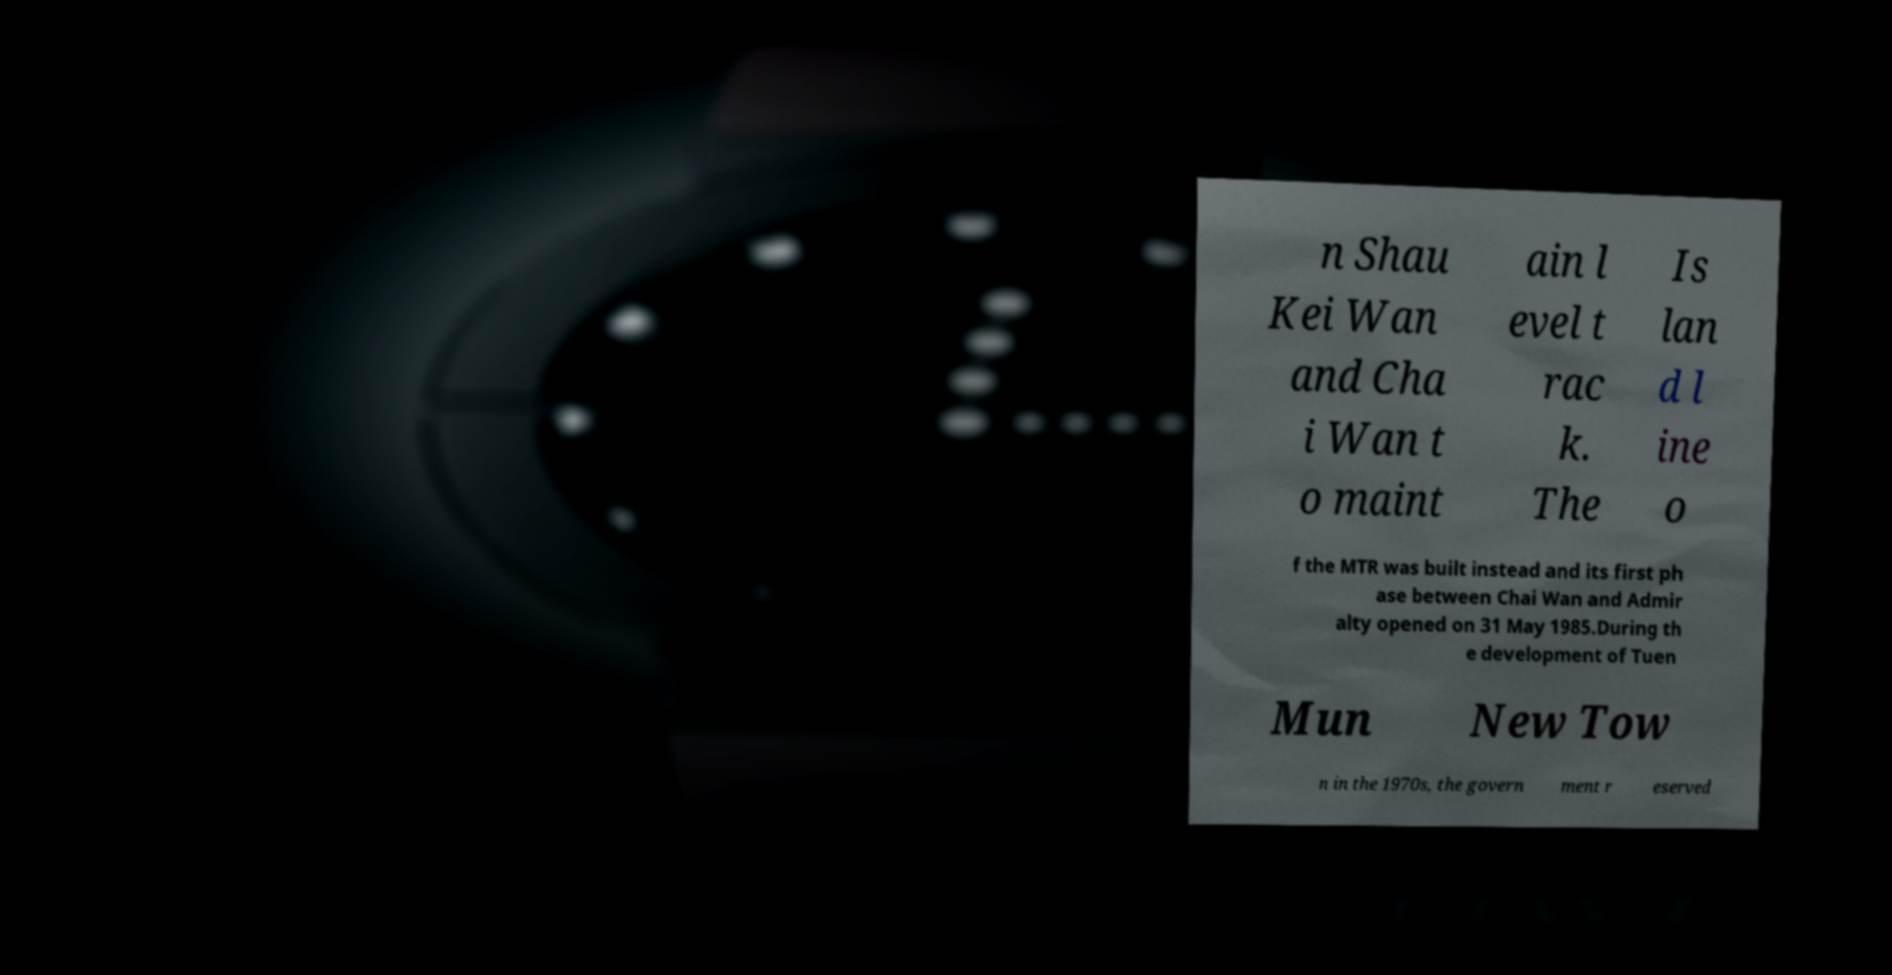I need the written content from this picture converted into text. Can you do that? n Shau Kei Wan and Cha i Wan t o maint ain l evel t rac k. The Is lan d l ine o f the MTR was built instead and its first ph ase between Chai Wan and Admir alty opened on 31 May 1985.During th e development of Tuen Mun New Tow n in the 1970s, the govern ment r eserved 